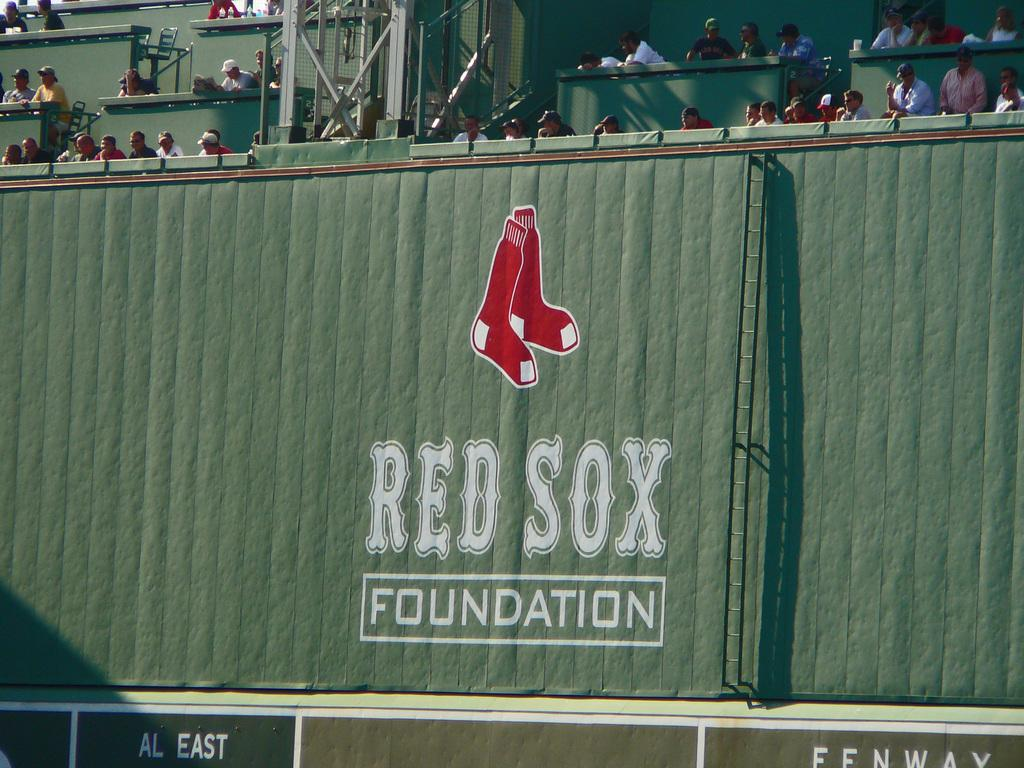<image>
Give a short and clear explanation of the subsequent image. People sit behind a wall that says Red Sox Foundation. 